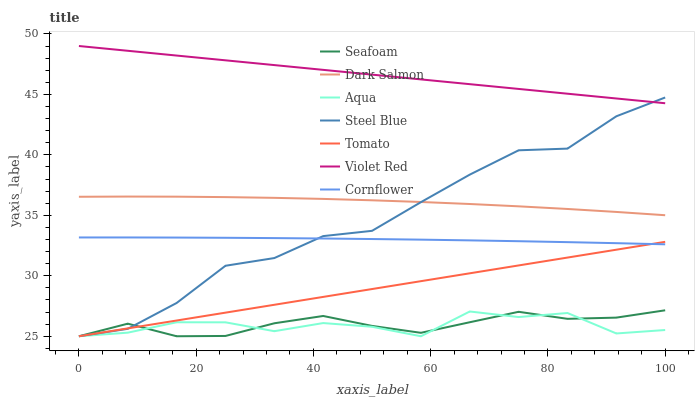Does Cornflower have the minimum area under the curve?
Answer yes or no. No. Does Cornflower have the maximum area under the curve?
Answer yes or no. No. Is Cornflower the smoothest?
Answer yes or no. No. Is Cornflower the roughest?
Answer yes or no. No. Does Cornflower have the lowest value?
Answer yes or no. No. Does Cornflower have the highest value?
Answer yes or no. No. Is Cornflower less than Dark Salmon?
Answer yes or no. Yes. Is Violet Red greater than Tomato?
Answer yes or no. Yes. Does Cornflower intersect Dark Salmon?
Answer yes or no. No. 